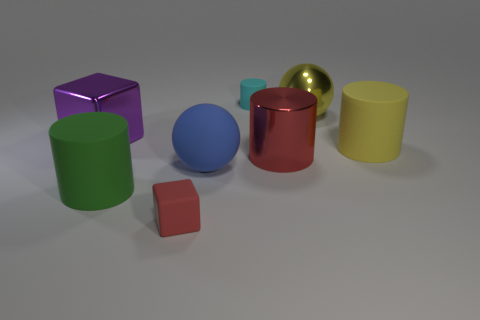Subtract all cyan cylinders. Subtract all cyan blocks. How many cylinders are left? 3 Add 2 green things. How many objects exist? 10 Subtract all spheres. How many objects are left? 6 Add 7 large green rubber things. How many large green rubber things exist? 8 Subtract 0 red spheres. How many objects are left? 8 Subtract all big gray balls. Subtract all yellow metal balls. How many objects are left? 7 Add 6 large green rubber cylinders. How many large green rubber cylinders are left? 7 